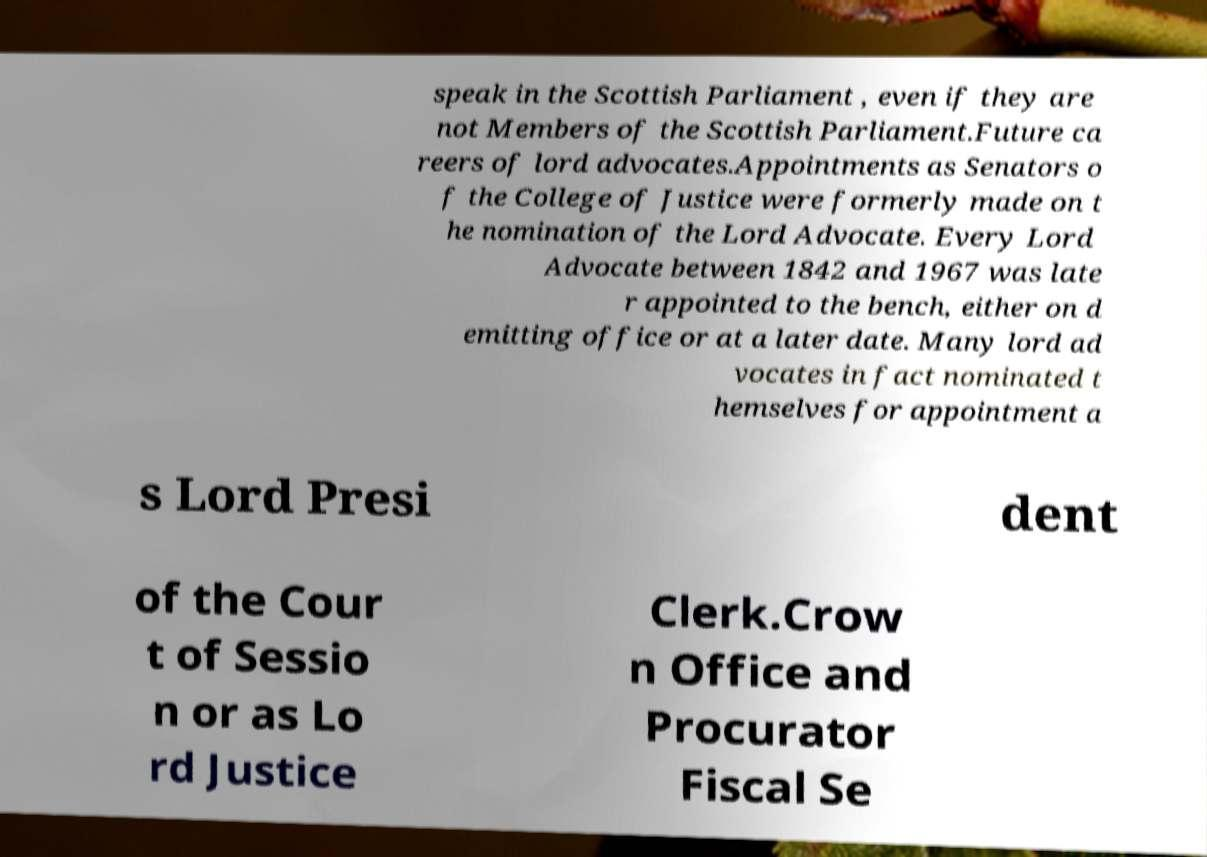Can you accurately transcribe the text from the provided image for me? speak in the Scottish Parliament , even if they are not Members of the Scottish Parliament.Future ca reers of lord advocates.Appointments as Senators o f the College of Justice were formerly made on t he nomination of the Lord Advocate. Every Lord Advocate between 1842 and 1967 was late r appointed to the bench, either on d emitting office or at a later date. Many lord ad vocates in fact nominated t hemselves for appointment a s Lord Presi dent of the Cour t of Sessio n or as Lo rd Justice Clerk.Crow n Office and Procurator Fiscal Se 